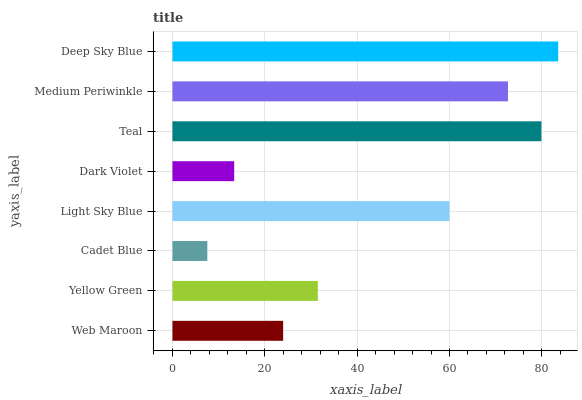Is Cadet Blue the minimum?
Answer yes or no. Yes. Is Deep Sky Blue the maximum?
Answer yes or no. Yes. Is Yellow Green the minimum?
Answer yes or no. No. Is Yellow Green the maximum?
Answer yes or no. No. Is Yellow Green greater than Web Maroon?
Answer yes or no. Yes. Is Web Maroon less than Yellow Green?
Answer yes or no. Yes. Is Web Maroon greater than Yellow Green?
Answer yes or no. No. Is Yellow Green less than Web Maroon?
Answer yes or no. No. Is Light Sky Blue the high median?
Answer yes or no. Yes. Is Yellow Green the low median?
Answer yes or no. Yes. Is Medium Periwinkle the high median?
Answer yes or no. No. Is Cadet Blue the low median?
Answer yes or no. No. 